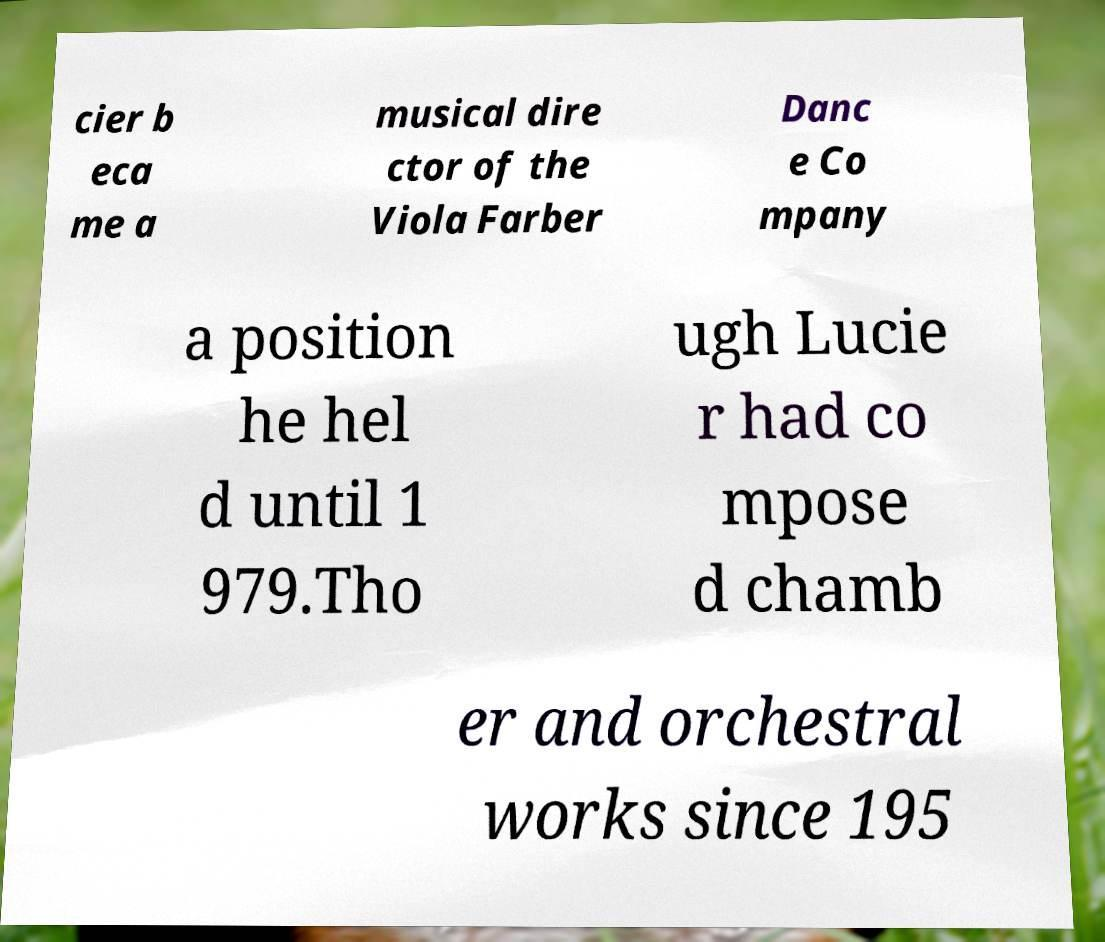What messages or text are displayed in this image? I need them in a readable, typed format. cier b eca me a musical dire ctor of the Viola Farber Danc e Co mpany a position he hel d until 1 979.Tho ugh Lucie r had co mpose d chamb er and orchestral works since 195 